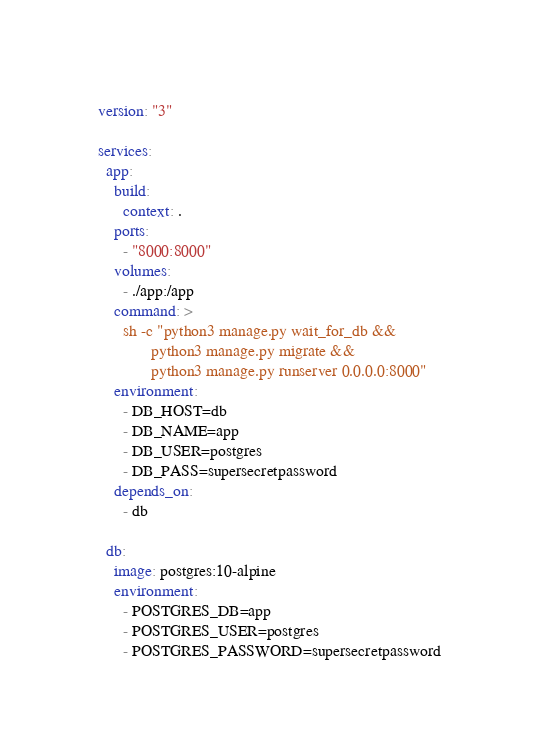Convert code to text. <code><loc_0><loc_0><loc_500><loc_500><_YAML_>version: "3"

services:
  app:
    build:
      context: .
    ports:
      - "8000:8000"
    volumes:
      - ./app:/app
    command: >
      sh -c "python3 manage.py wait_for_db &&
             python3 manage.py migrate &&
             python3 manage.py runserver 0.0.0.0:8000"
    environment:
      - DB_HOST=db
      - DB_NAME=app
      - DB_USER=postgres
      - DB_PASS=supersecretpassword
    depends_on:
      - db

  db:
    image: postgres:10-alpine
    environment:
      - POSTGRES_DB=app
      - POSTGRES_USER=postgres
      - POSTGRES_PASSWORD=supersecretpassword</code> 